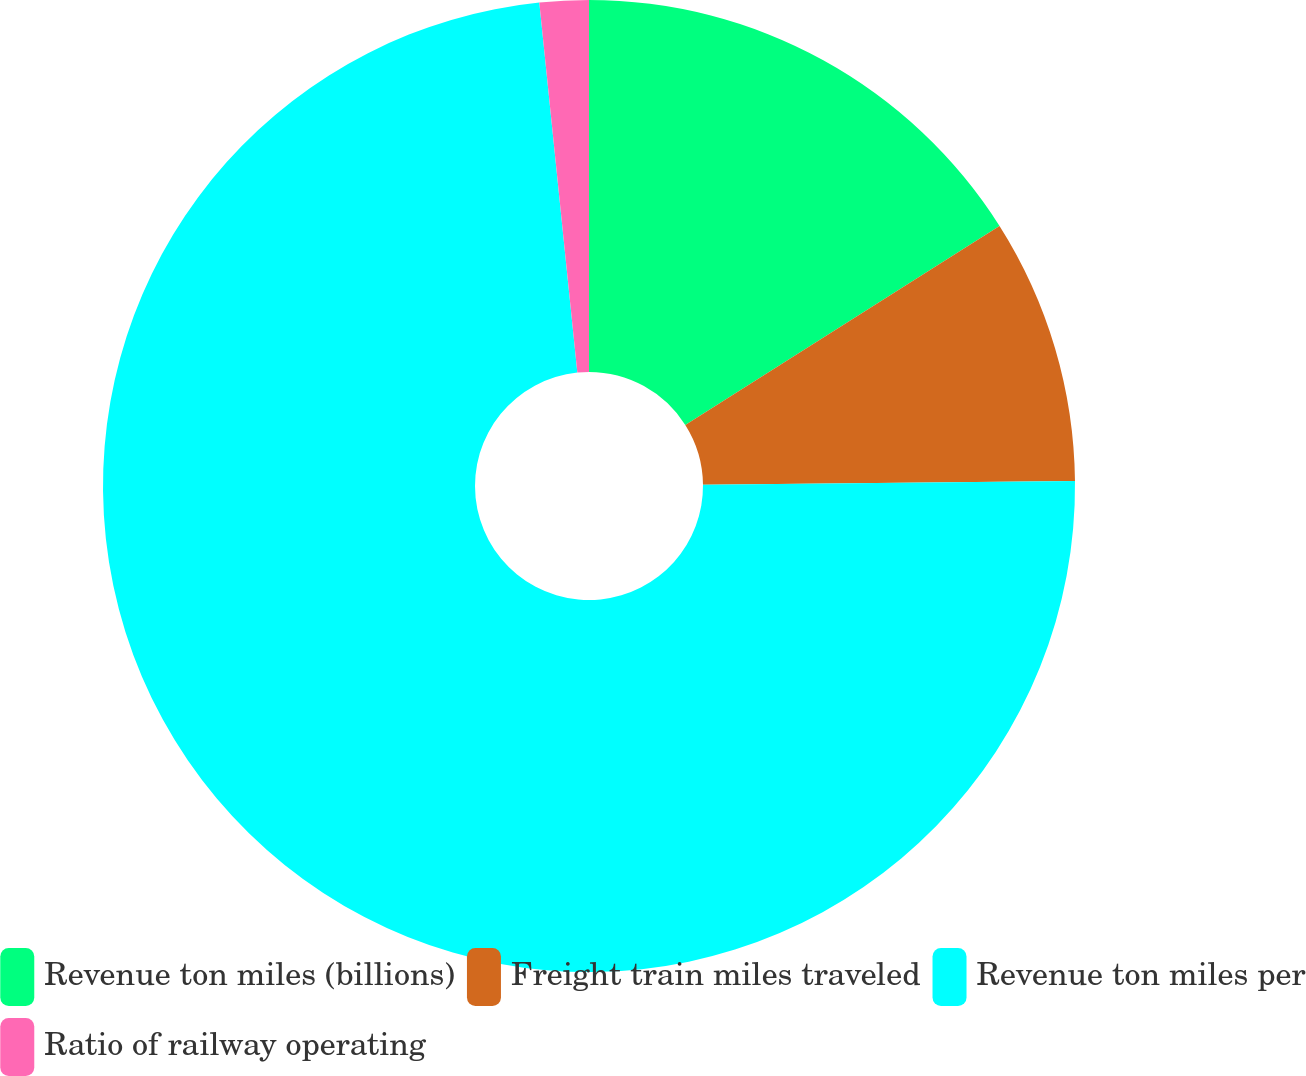Convert chart. <chart><loc_0><loc_0><loc_500><loc_500><pie_chart><fcel>Revenue ton miles (billions)<fcel>Freight train miles traveled<fcel>Revenue ton miles per<fcel>Ratio of railway operating<nl><fcel>16.01%<fcel>8.82%<fcel>73.53%<fcel>1.63%<nl></chart> 